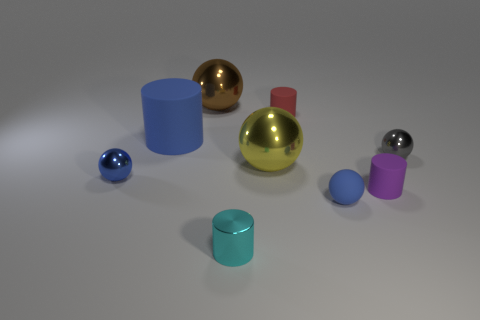Add 1 tiny red spheres. How many objects exist? 10 Subtract all large cylinders. How many cylinders are left? 3 Subtract 2 cylinders. How many cylinders are left? 2 Subtract all purple cylinders. How many cylinders are left? 3 Subtract all cylinders. How many objects are left? 5 Add 3 metallic spheres. How many metallic spheres are left? 7 Add 4 tiny rubber cylinders. How many tiny rubber cylinders exist? 6 Subtract 0 brown cubes. How many objects are left? 9 Subtract all brown balls. Subtract all cyan cylinders. How many balls are left? 4 Subtract all red blocks. How many blue balls are left? 2 